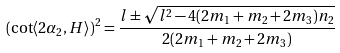Convert formula to latex. <formula><loc_0><loc_0><loc_500><loc_500>( \cot \langle 2 \alpha _ { 2 } , H \rangle ) ^ { 2 } = \frac { l \pm \sqrt { l ^ { 2 } - 4 ( 2 m _ { 1 } + m _ { 2 } + 2 m _ { 3 } ) n _ { 2 } } } { 2 ( 2 m _ { 1 } + m _ { 2 } + 2 m _ { 3 } ) }</formula> 